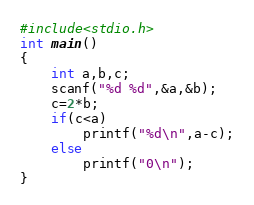<code> <loc_0><loc_0><loc_500><loc_500><_C_>#include<stdio.h>
int main()
{
    int a,b,c;
    scanf("%d %d",&a,&b);
    c=2*b;
    if(c<a)
        printf("%d\n",a-c);
    else
        printf("0\n");
}</code> 